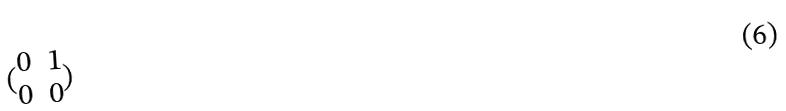Convert formula to latex. <formula><loc_0><loc_0><loc_500><loc_500>( \begin{matrix} 0 & 1 \\ 0 & 0 \end{matrix} )</formula> 